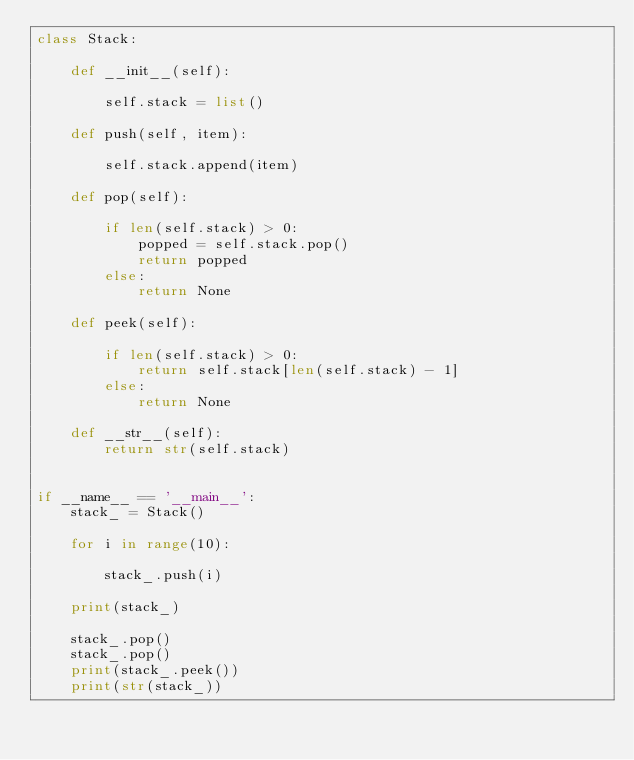Convert code to text. <code><loc_0><loc_0><loc_500><loc_500><_Python_>class Stack:

    def __init__(self):

        self.stack = list()

    def push(self, item):

        self.stack.append(item)

    def pop(self):

        if len(self.stack) > 0:
            popped = self.stack.pop()
            return popped
        else:
            return None

    def peek(self):

        if len(self.stack) > 0:
            return self.stack[len(self.stack) - 1]
        else:
            return None

    def __str__(self):
        return str(self.stack)


if __name__ == '__main__':
    stack_ = Stack()

    for i in range(10):

        stack_.push(i)

    print(stack_)

    stack_.pop()
    stack_.pop()
    print(stack_.peek())
    print(str(stack_))
</code> 